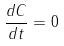Convert formula to latex. <formula><loc_0><loc_0><loc_500><loc_500>\frac { d C } { d t } = 0</formula> 